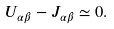<formula> <loc_0><loc_0><loc_500><loc_500>U _ { \alpha \beta } - J _ { \alpha \beta } \simeq 0 .</formula> 